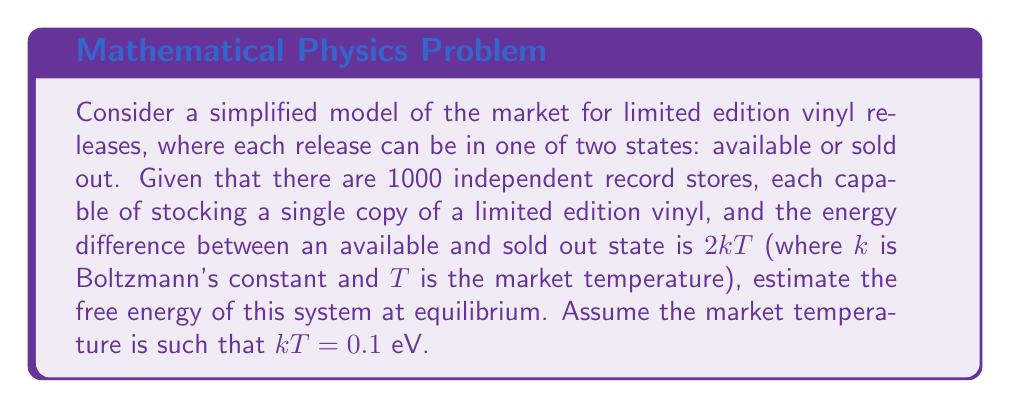Could you help me with this problem? To estimate the free energy of this system, we'll use the canonical ensemble approach:

1. First, we need to calculate the partition function Z:
   $$Z = \sum_i e^{-E_i/kT}$$
   In our case, we have two states for each store: available (E = 0) and sold out (E = 2kT)
   $$Z = e^0 + e^{-2} = 1 + e^{-2}$$

2. For 1000 independent stores, the total partition function is:
   $$Z_{total} = (1 + e^{-2})^{1000}$$

3. The free energy F is related to the partition function by:
   $$F = -kT \ln Z_{total}$$

4. Substituting our partition function:
   $$F = -kT \ln (1 + e^{-2})^{1000}$$

5. Using the properties of logarithms:
   $$F = -1000 kT \ln (1 + e^{-2})$$

6. Given that kT = 0.1 eV:
   $$F = -100 \cdot \ln (1 + e^{-2}) \text{ eV}$$

7. Calculating the numerical value:
   $$F \approx -12.20 \text{ eV}$$
Answer: $-12.20 \text{ eV}$ 